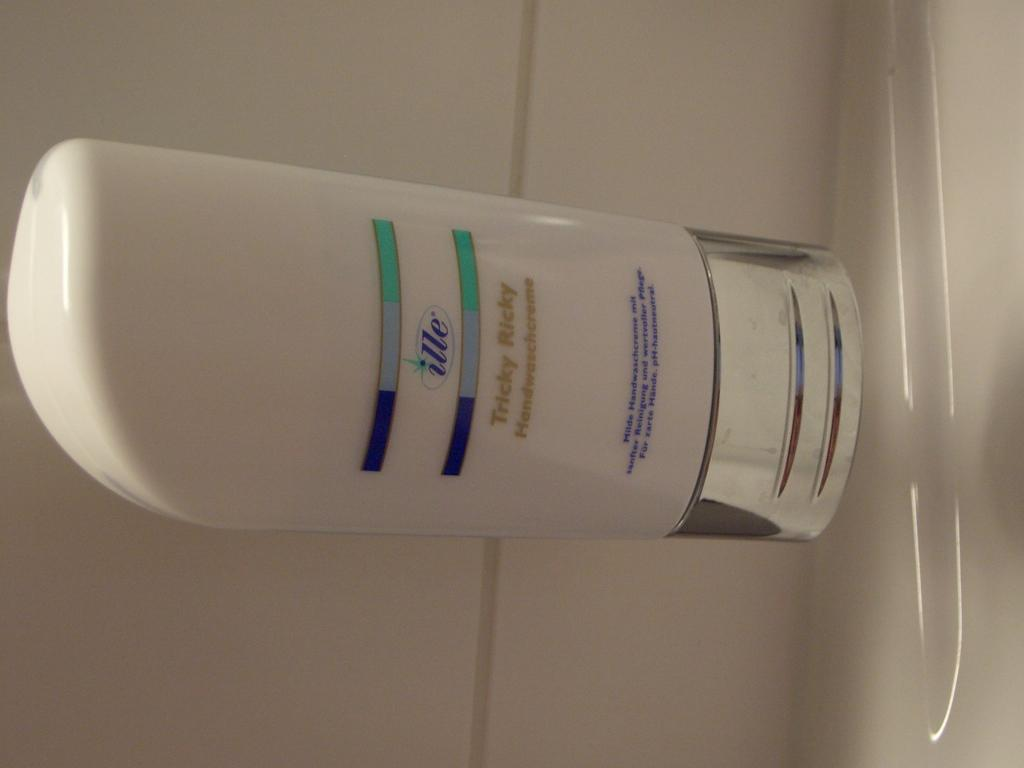<image>
Give a short and clear explanation of the subsequent image. A bottle of Ille conditioner lies on a white counter. 